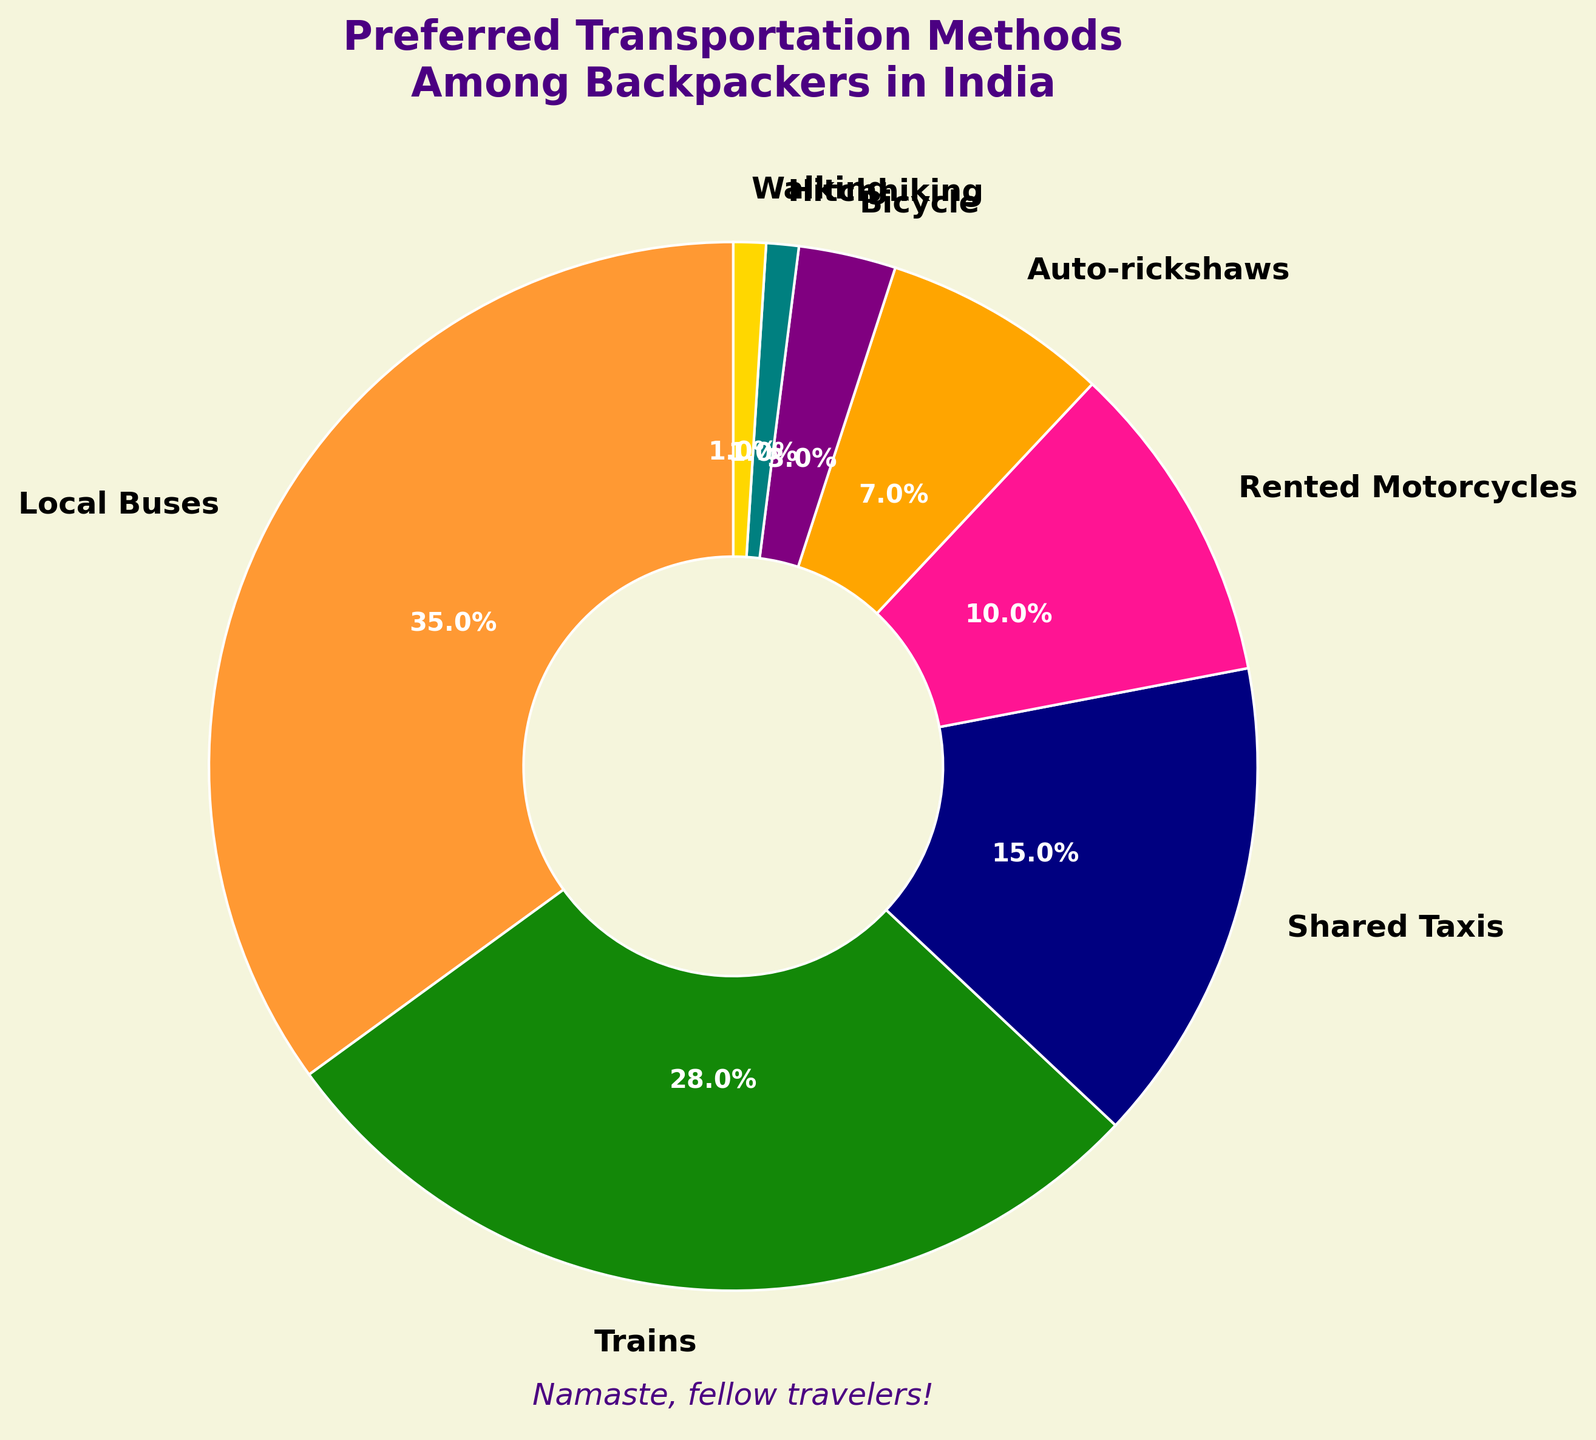What is the most preferred transportation method among backpackers in India? By looking at the pie chart, we can see the transportation method with the largest section. Since Local Buses occupy the largest slice of the pie, it is the most preferred method.
Answer: Local Buses Which transportation method is used more frequently, Trains or Auto-rickshaws? The pie chart shows percentages for each transportation method. Trains (28%) have a larger percentage compared to Auto-rickshaws (7%).
Answer: Trains What is the combined percentage of Shared Taxis and Rented Motorcycles? We need to add the percentages of Shared Taxis (15%) and Rented Motorcycles (10%). Therefore, 15% + 10% = 25%.
Answer: 25% How does the percentage of backpackers who prefer Local Buses compare to those who prefer Trains? We need to compare the two percentages: Local Buses (35%) and Trains (28%). Since 35% is greater than 28%, Local Buses are preferred by a larger percentage of backpackers than Trains.
Answer: Local Buses are preferred by a larger percentage What is the least preferred transportation method among backpackers? By looking at the smallest section of the pie chart, we see that Hitchhiking and Walking each occupy 1% of the pie, making them the least preferred methods.
Answer: Hitchhiking and Walking Which method is used more, Bicycles or Auto-rickshaws? The pie chart shows that Auto-rickshaws (7%) are used more than Bicycles (3%).
Answer: Auto-rickshaws What is the cumulative percentage of walking, hitchhiking, and bicycles? Adding the percentages for Walking (1%), Hitchhiking (1%), and Bicycles (3%) gives 1% + 1% + 3% = 5%.
Answer: 5% Compare the usage of Shared Taxis to Rented Motorcycles in terms of percentage difference. The percentages are 15% for Shared Taxis and 10% for Rented Motorcycles. The difference is calculated as 15% - 10% = 5%.
Answer: 5% What percentage of backpackers prefer individual transportation methods (Rented Motorcycles and Bicycles combined)? Adding the percentages for Rented Motorcycles (10%) and Bicycles (3%) gives 10% + 3% = 13%.
Answer: 13% What transportation method falls between the largest (Local Buses) and the smallest (Hitchhiking and Walking) in terms of percentage? The pie chart reveals that the next transportation method in descending order after Local Buses (35%) is Trains (28%), and just above Hitchhiking and Walking (1%) are Bicycles (3%). Every method between these values should be ranked: Trains, Shared Taxis, Rented Motorcycles, Auto-rickshaws, and Bicycles.
Answer: Trains, Shared Taxis, Rented Motorcycles, Auto-rickshaws, Bicycles 